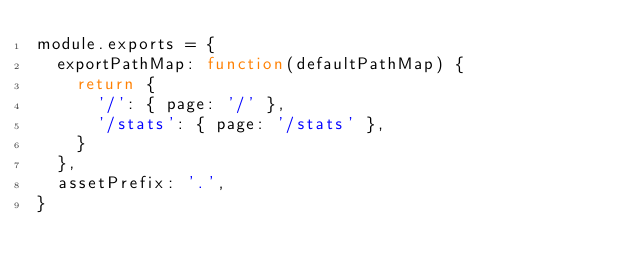Convert code to text. <code><loc_0><loc_0><loc_500><loc_500><_JavaScript_>module.exports = {
  exportPathMap: function(defaultPathMap) {
    return {
      '/': { page: '/' },
      '/stats': { page: '/stats' },
    }
  },
  assetPrefix: '.',
}
</code> 